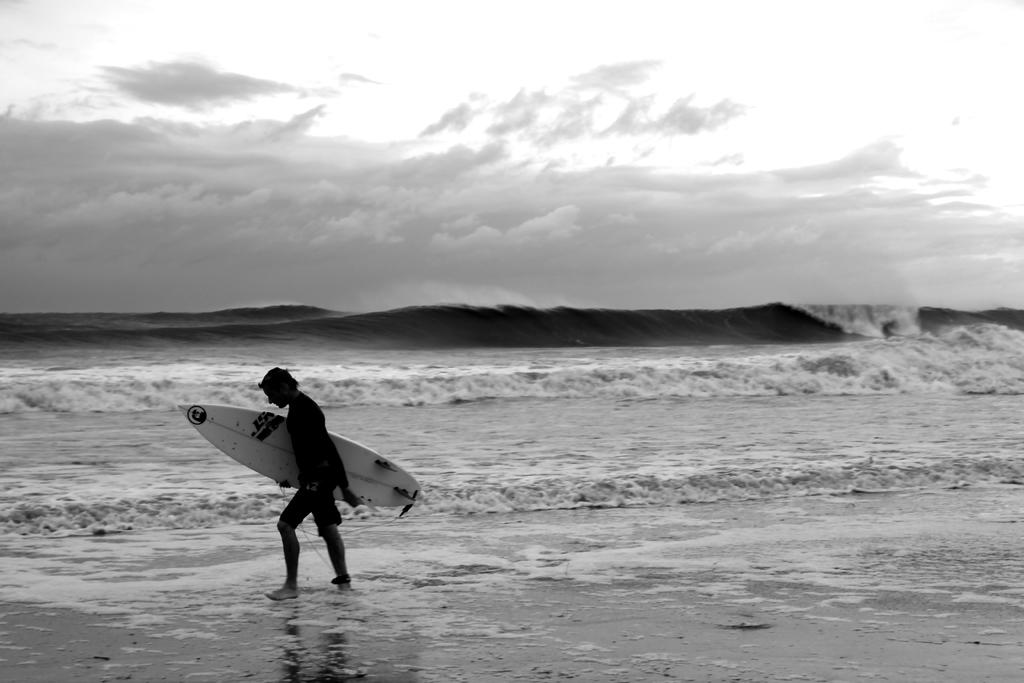What type of natural body of water is visible in the image? There is a sea in the image. What can be observed about the sea in the image? There are waves in the sea. What type of land is adjacent to the sea in the image? There is a beach in the image. What is the person on the beach doing? The person is walking on the beach and holding a surfer board. What type of gold object can be seen in the image? There is no gold object present in the image. What type of beast can be seen on the beach in the image? There are no beasts present in the image; only a person holding a surfer board can be seen. 